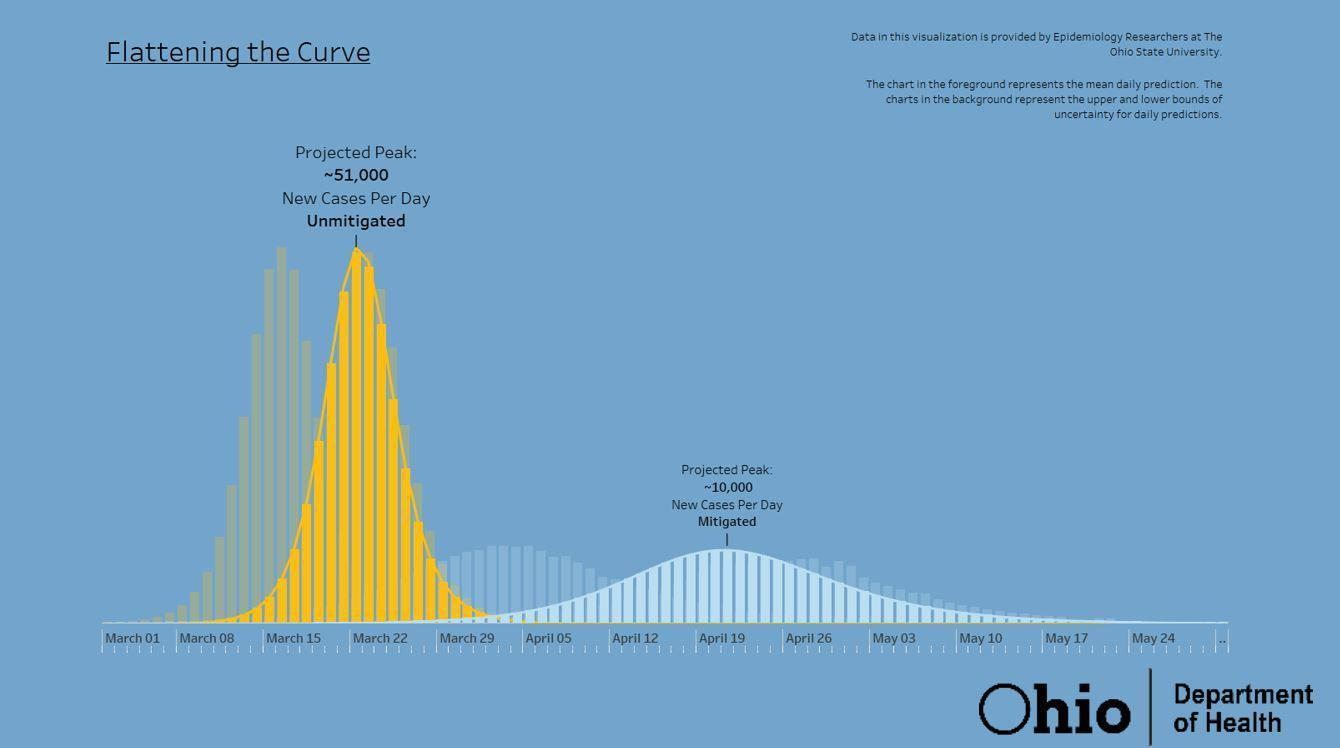How many months are mentioned in the graph?
Answer the question with a short phrase. 3 What is the difference between the two projected peaks? 41,000 